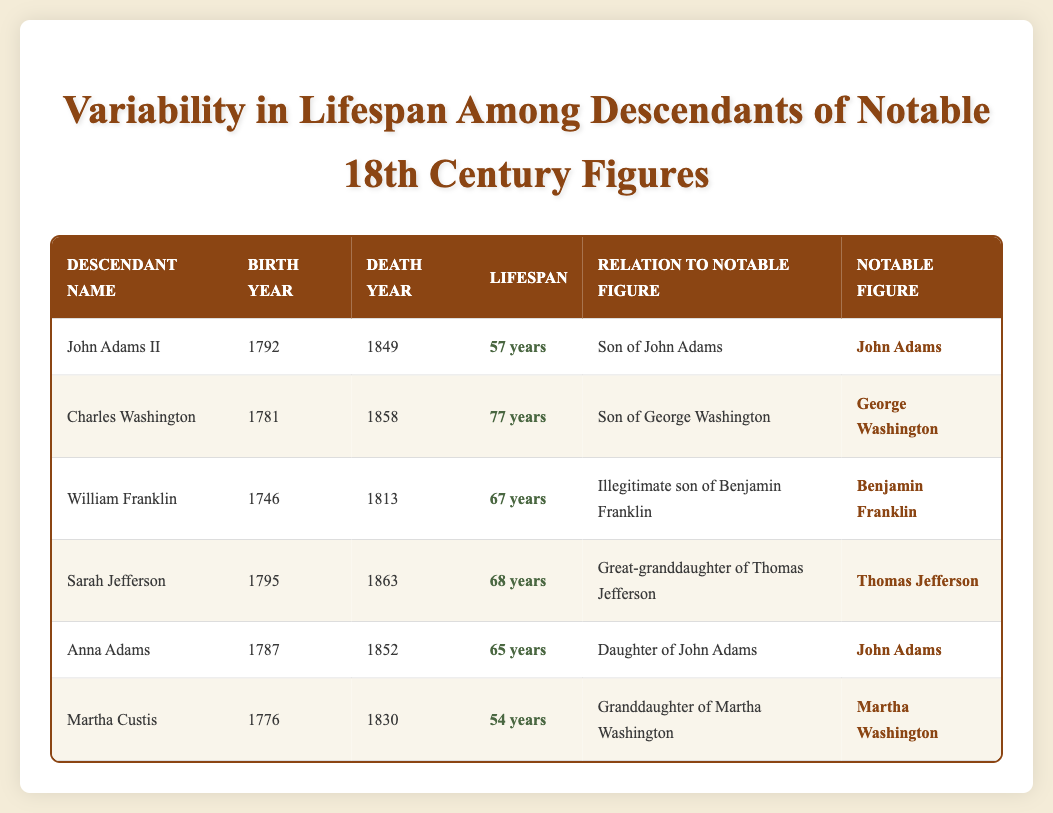What is the lifespan of Sarah Jefferson? From the table, the lifespan of Sarah Jefferson is listed under the "Lifespan" column which says "68 years."
Answer: 68 years Who is the descendant of George Washington? Looking through the "Relation to Notable Figure" column, Charles Washington is identified as the "Son of George Washington."
Answer: Charles Washington Did any descendant live over 70 years? Checking the "Lifespan" column, we see that Charles Washington lived for 77 years, which is over 70 years.
Answer: Yes Who has the shortest lifespan among the listed descendants? By comparing the "Lifespan" column values: 57 (John Adams II), 77 (Charles Washington), 67 (William Franklin), 68 (Sarah Jefferson), 65 (Anna Adams), and 54 (Martha Custis), we see Martha Custis has the shortest at 54 years.
Answer: Martha Custis What is the average lifespan of the descendants of John Adams? The descendants of John Adams listed are John Adams II (57 years) and Anna Adams (65 years). To find the average, add their lifespans: 57 + 65 = 122 years, then divide by 2 (the number of descendants): 122 / 2 = 61 years.
Answer: 61 years Is there a daughter among the descendants listed? The "Relation to Notable Figure" column indicates that Anna Adams is noted as the "Daughter of John Adams."
Answer: Yes What notable figure has the highest lifespan from the listed descendants? Evaluating the "Lifespan" column: 54 (Martha Custis), 57 (John Adams II), 67 (William Franklin), 68 (Sarah Jefferson), 65 (Anna Adams), and 77 (Charles Washington), we see Charles Washington has the highest lifespan at 77 years.
Answer: Charles Washington What is the total lifespan of all the descendants listed in the table? The total lifespan is calculated by summing the values in the "Lifespan" column: 57 (John Adams II) + 77 (Charles Washington) + 67 (William Franklin) + 68 (Sarah Jefferson) + 65 (Anna Adams) + 54 (Martha Custis) = 405 years.
Answer: 405 years 